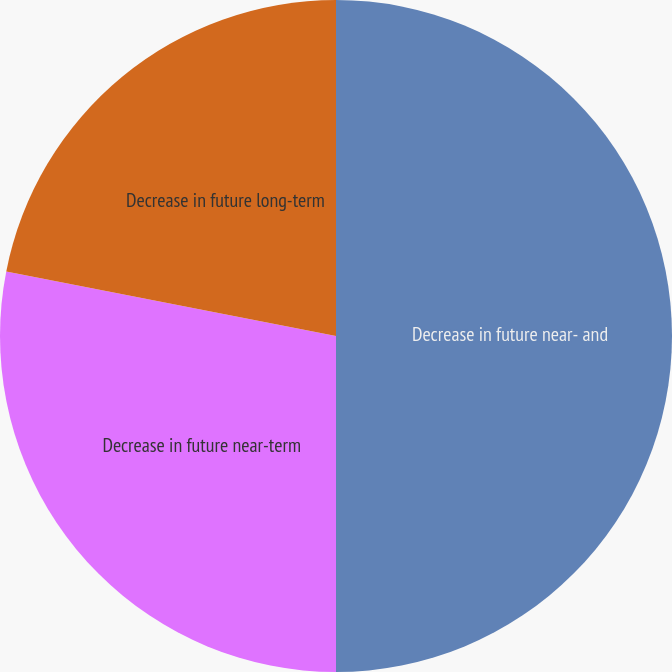Convert chart. <chart><loc_0><loc_0><loc_500><loc_500><pie_chart><fcel>Decrease in future near- and<fcel>Decrease in future near-term<fcel>Decrease in future long-term<nl><fcel>50.0%<fcel>28.08%<fcel>21.92%<nl></chart> 